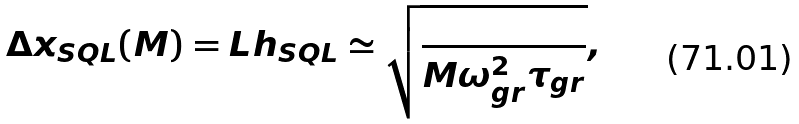<formula> <loc_0><loc_0><loc_500><loc_500>\Delta x _ { S Q L } ( M ) = L h _ { S Q L } \simeq \sqrt { \frac { } { M \omega _ { g r } ^ { 2 } \tau _ { g r } } } ,</formula> 